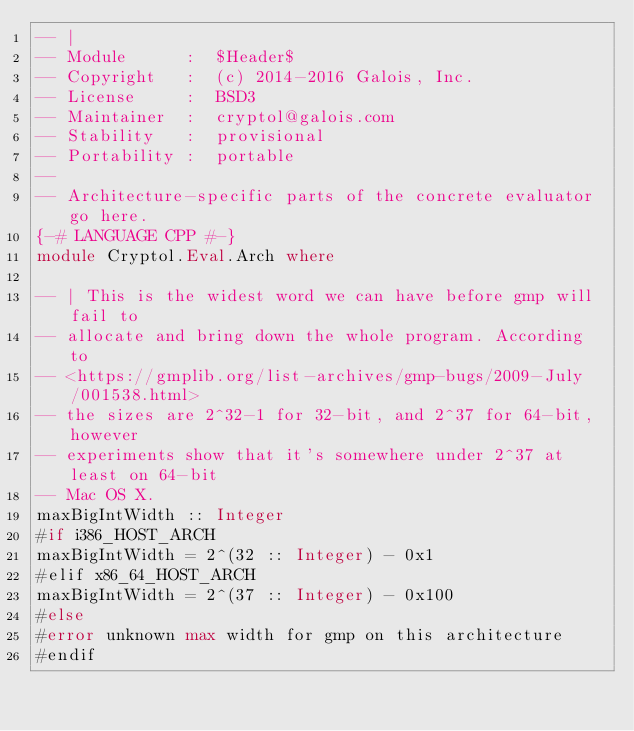<code> <loc_0><loc_0><loc_500><loc_500><_Haskell_>-- |
-- Module      :  $Header$
-- Copyright   :  (c) 2014-2016 Galois, Inc.
-- License     :  BSD3
-- Maintainer  :  cryptol@galois.com
-- Stability   :  provisional
-- Portability :  portable
--
-- Architecture-specific parts of the concrete evaluator go here.
{-# LANGUAGE CPP #-}
module Cryptol.Eval.Arch where

-- | This is the widest word we can have before gmp will fail to
-- allocate and bring down the whole program. According to
-- <https://gmplib.org/list-archives/gmp-bugs/2009-July/001538.html>
-- the sizes are 2^32-1 for 32-bit, and 2^37 for 64-bit, however
-- experiments show that it's somewhere under 2^37 at least on 64-bit
-- Mac OS X.
maxBigIntWidth :: Integer
#if i386_HOST_ARCH
maxBigIntWidth = 2^(32 :: Integer) - 0x1
#elif x86_64_HOST_ARCH
maxBigIntWidth = 2^(37 :: Integer) - 0x100
#else
#error unknown max width for gmp on this architecture
#endif
</code> 